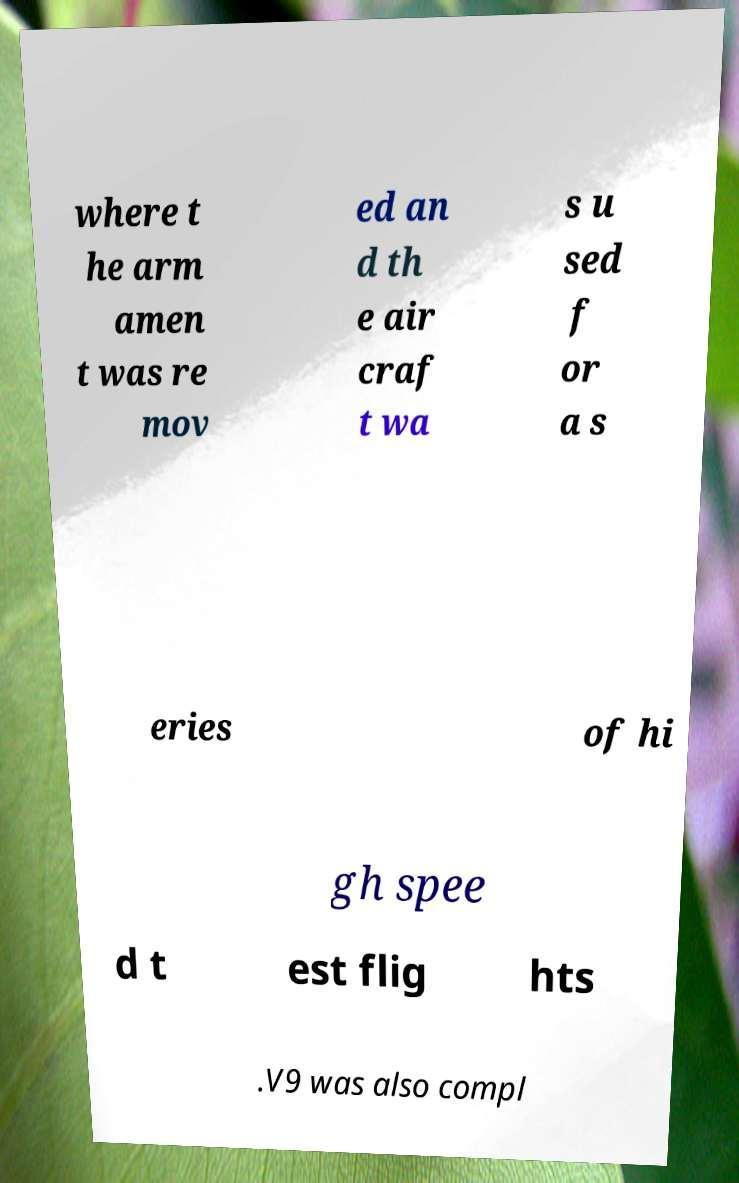For documentation purposes, I need the text within this image transcribed. Could you provide that? where t he arm amen t was re mov ed an d th e air craf t wa s u sed f or a s eries of hi gh spee d t est flig hts .V9 was also compl 